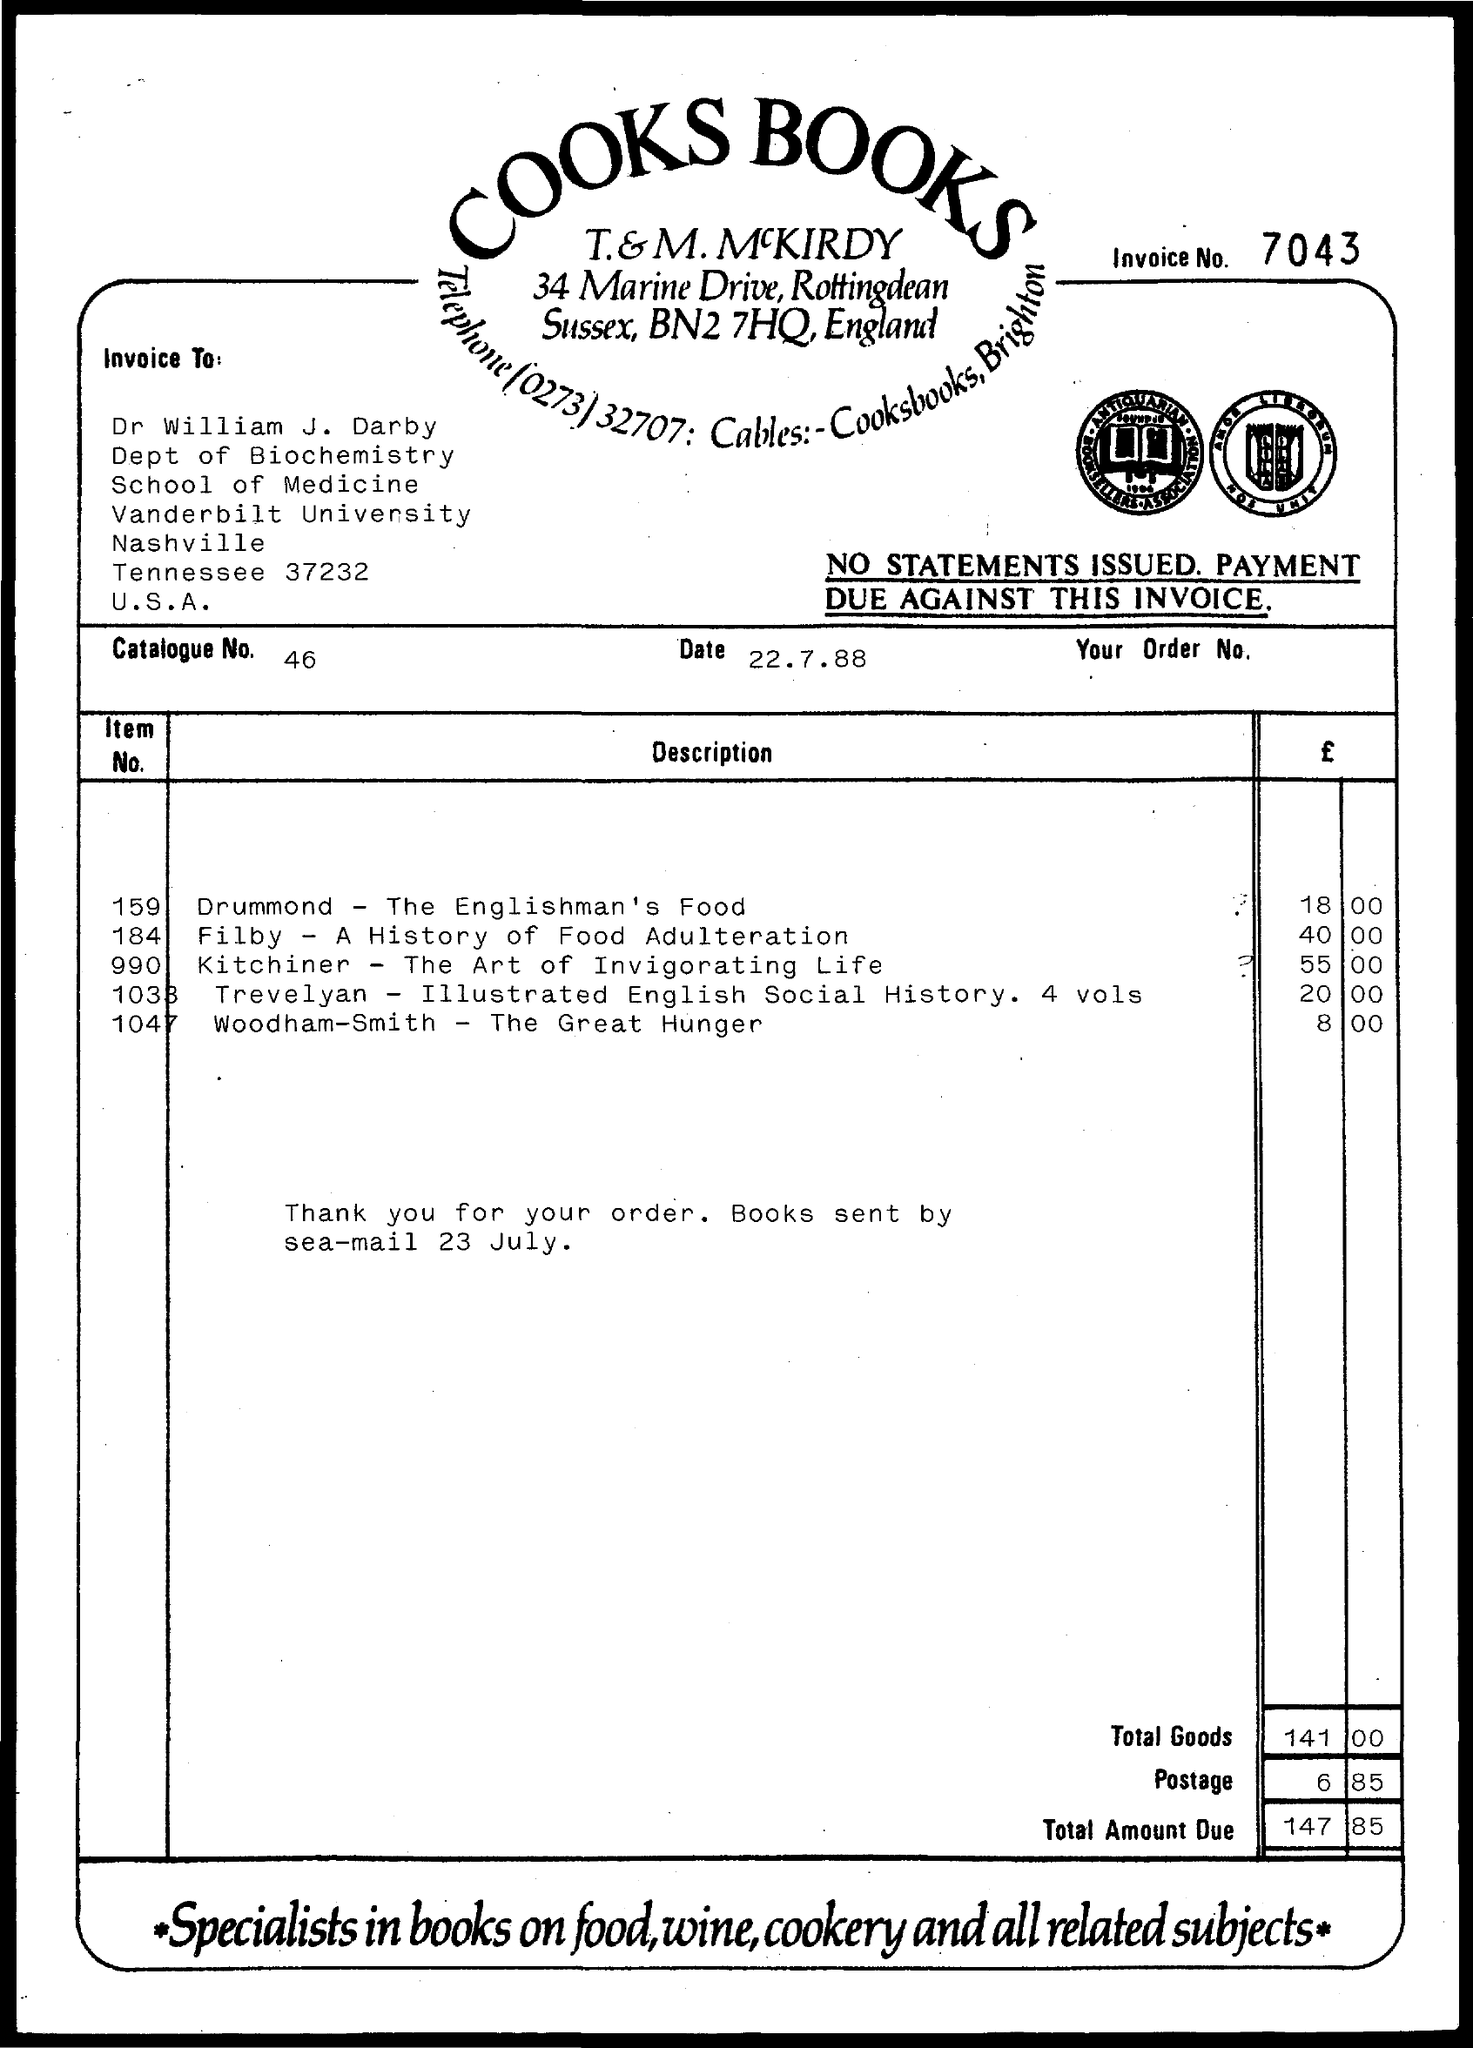What is the Invoice Number?
Ensure brevity in your answer.  7043. Who is this Invoice "to"?
Your answer should be very brief. Dr William J. Darby. What is the Catalogue No.?
Offer a very short reply. 46. What is the Date?
Offer a terse response. 22.7.88. What is the Price for Item No. 159?
Offer a very short reply. 18.00. What is the Price for Item No. 184?
Offer a terse response. 40 00. What is the Price for Item No. 990?
Give a very brief answer. 55.00. What is the Total goods?
Offer a terse response. 141 00. What is the Postage?
Your answer should be compact. 6.85. What is the Total amount due?
Provide a short and direct response. 147.85. 